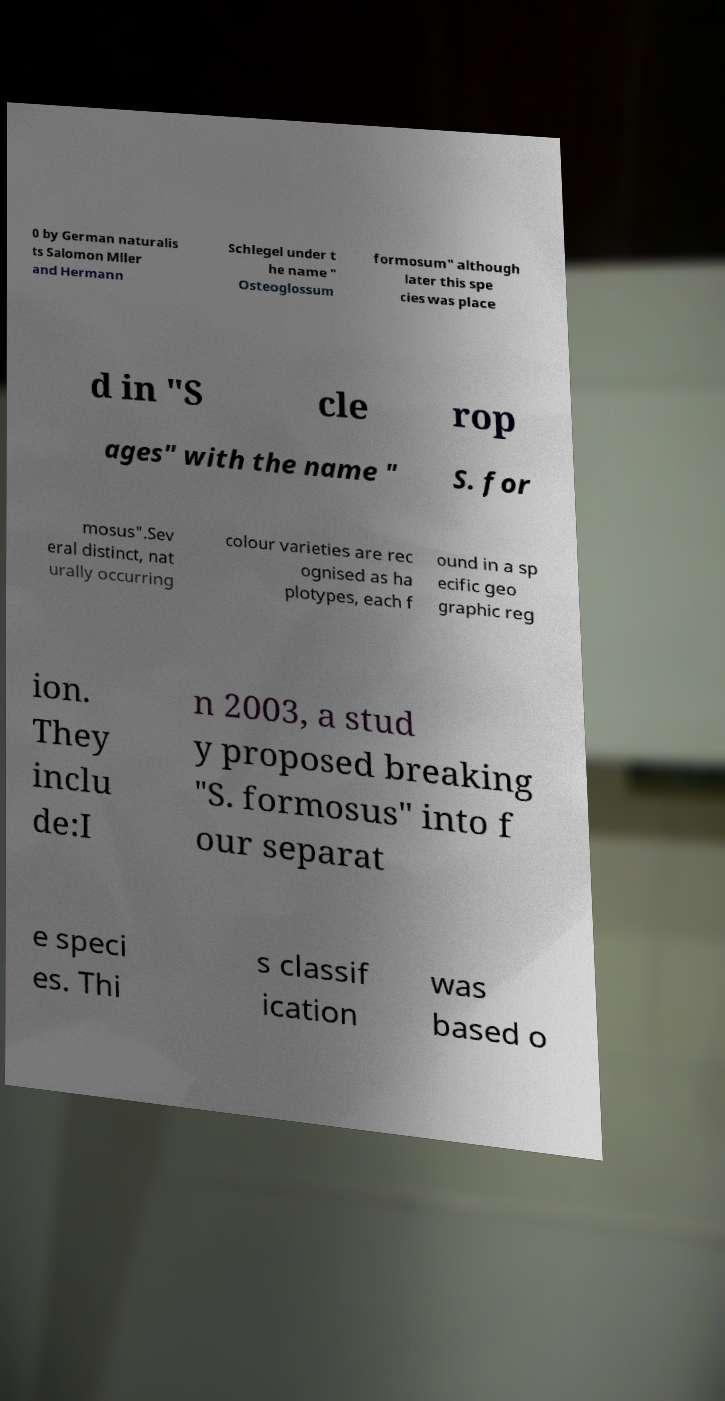Can you read and provide the text displayed in the image?This photo seems to have some interesting text. Can you extract and type it out for me? 0 by German naturalis ts Salomon Mller and Hermann Schlegel under t he name " Osteoglossum formosum" although later this spe cies was place d in "S cle rop ages" with the name " S. for mosus".Sev eral distinct, nat urally occurring colour varieties are rec ognised as ha plotypes, each f ound in a sp ecific geo graphic reg ion. They inclu de:I n 2003, a stud y proposed breaking "S. formosus" into f our separat e speci es. Thi s classif ication was based o 